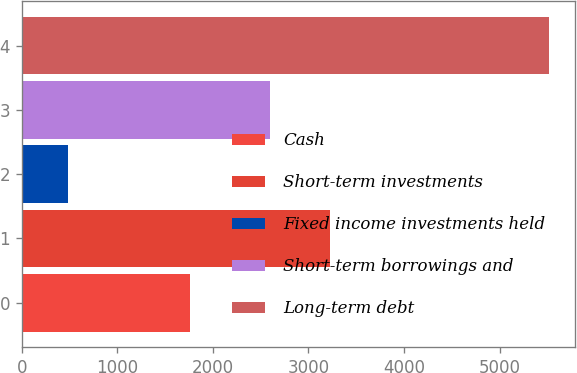Convert chart. <chart><loc_0><loc_0><loc_500><loc_500><bar_chart><fcel>Cash<fcel>Short-term investments<fcel>Fixed income investments held<fcel>Short-term borrowings and<fcel>Long-term debt<nl><fcel>1764<fcel>3226<fcel>484<fcel>2595<fcel>5517<nl></chart> 